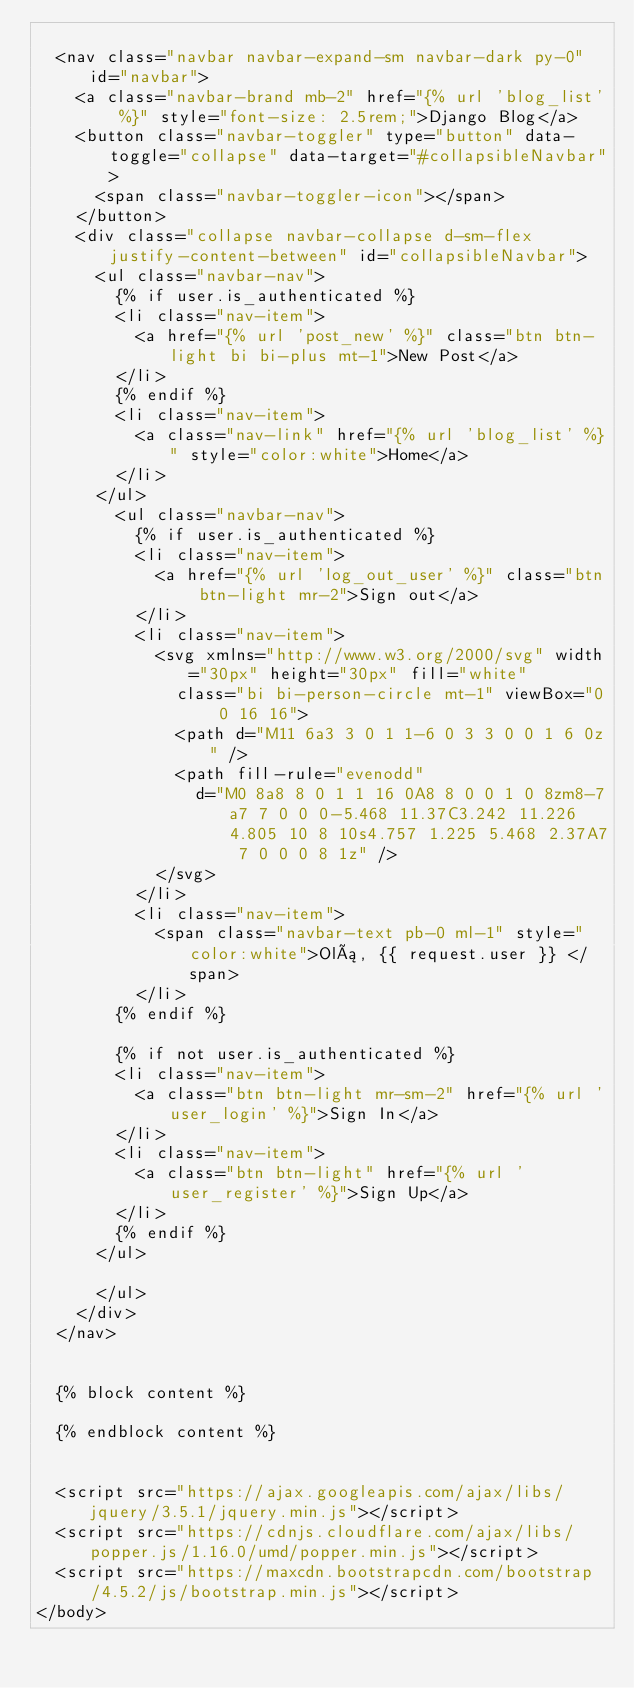<code> <loc_0><loc_0><loc_500><loc_500><_HTML_>
  <nav class="navbar navbar-expand-sm navbar-dark py-0" id="navbar">
    <a class="navbar-brand mb-2" href="{% url 'blog_list' %}" style="font-size: 2.5rem;">Django Blog</a>
    <button class="navbar-toggler" type="button" data-toggle="collapse" data-target="#collapsibleNavbar">
      <span class="navbar-toggler-icon"></span>
    </button>
    <div class="collapse navbar-collapse d-sm-flex justify-content-between" id="collapsibleNavbar">
      <ul class="navbar-nav">
        {% if user.is_authenticated %}
        <li class="nav-item">
          <a href="{% url 'post_new' %}" class="btn btn-light bi bi-plus mt-1">New Post</a>
        </li>
        {% endif %}
        <li class="nav-item">
          <a class="nav-link" href="{% url 'blog_list' %}" style="color:white">Home</a>
        </li>
      </ul>
        <ul class="navbar-nav">
          {% if user.is_authenticated %}  
          <li class="nav-item">
            <a href="{% url 'log_out_user' %}" class="btn btn-light mr-2">Sign out</a>
          </li>
          <li class="nav-item">
            <svg xmlns="http://www.w3.org/2000/svg" width="30px" height="30px" fill="white"
              class="bi bi-person-circle mt-1" viewBox="0 0 16 16">
              <path d="M11 6a3 3 0 1 1-6 0 3 3 0 0 1 6 0z" />
              <path fill-rule="evenodd"
                d="M0 8a8 8 0 1 1 16 0A8 8 0 0 1 0 8zm8-7a7 7 0 0 0-5.468 11.37C3.242 11.226 4.805 10 8 10s4.757 1.225 5.468 2.37A7 7 0 0 0 8 1z" />
            </svg>
          </li>
          <li class="nav-item">
            <span class="navbar-text pb-0 ml-1" style="color:white">Olá, {{ request.user }} </span>
          </li>
        {% endif %}

        {% if not user.is_authenticated %}
        <li class="nav-item">
          <a class="btn btn-light mr-sm-2" href="{% url 'user_login' %}">Sign In</a>
        </li>
        <li class="nav-item">
          <a class="btn btn-light" href="{% url 'user_register' %}">Sign Up</a>
        </li>
        {% endif %}
      </ul>
        
      </ul>
    </div>
  </nav>


  {% block content %}

  {% endblock content %}


  <script src="https://ajax.googleapis.com/ajax/libs/jquery/3.5.1/jquery.min.js"></script>
  <script src="https://cdnjs.cloudflare.com/ajax/libs/popper.js/1.16.0/umd/popper.min.js"></script>
  <script src="https://maxcdn.bootstrapcdn.com/bootstrap/4.5.2/js/bootstrap.min.js"></script>
</body></code> 